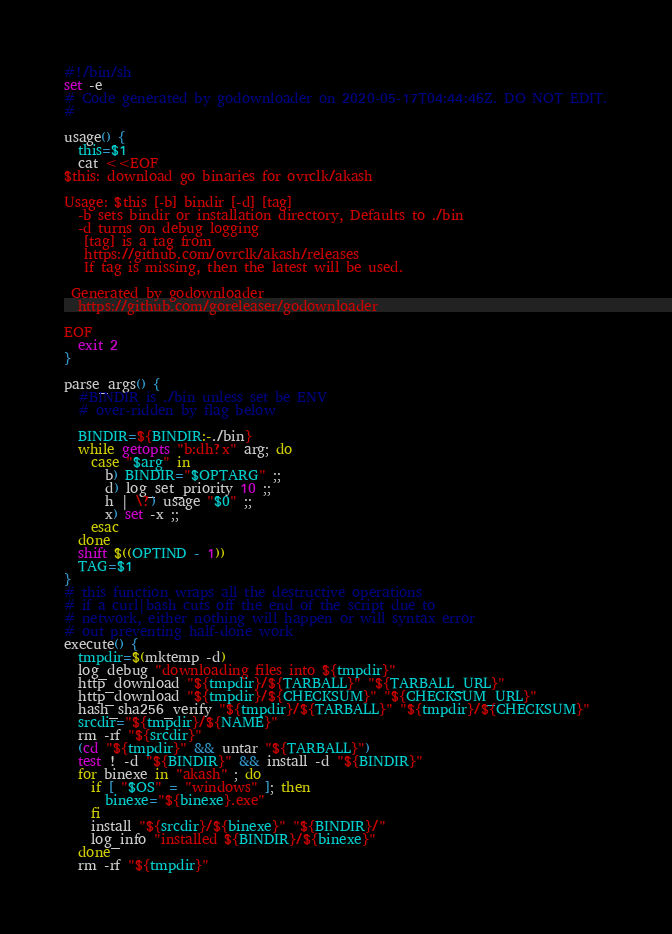<code> <loc_0><loc_0><loc_500><loc_500><_Bash_>#!/bin/sh
set -e
# Code generated by godownloader on 2020-05-17T04:44:46Z. DO NOT EDIT.
#

usage() {
  this=$1
  cat <<EOF
$this: download go binaries for ovrclk/akash

Usage: $this [-b] bindir [-d] [tag]
  -b sets bindir or installation directory, Defaults to ./bin
  -d turns on debug logging
   [tag] is a tag from
   https://github.com/ovrclk/akash/releases
   If tag is missing, then the latest will be used.

 Generated by godownloader
  https://github.com/goreleaser/godownloader

EOF
  exit 2
}

parse_args() {
  #BINDIR is ./bin unless set be ENV
  # over-ridden by flag below

  BINDIR=${BINDIR:-./bin}
  while getopts "b:dh?x" arg; do
    case "$arg" in
      b) BINDIR="$OPTARG" ;;
      d) log_set_priority 10 ;;
      h | \?) usage "$0" ;;
      x) set -x ;;
    esac
  done
  shift $((OPTIND - 1))
  TAG=$1
}
# this function wraps all the destructive operations
# if a curl|bash cuts off the end of the script due to
# network, either nothing will happen or will syntax error
# out preventing half-done work
execute() {
  tmpdir=$(mktemp -d)
  log_debug "downloading files into ${tmpdir}"
  http_download "${tmpdir}/${TARBALL}" "${TARBALL_URL}"
  http_download "${tmpdir}/${CHECKSUM}" "${CHECKSUM_URL}"
  hash_sha256_verify "${tmpdir}/${TARBALL}" "${tmpdir}/${CHECKSUM}"
  srcdir="${tmpdir}/${NAME}"
  rm -rf "${srcdir}"
  (cd "${tmpdir}" && untar "${TARBALL}")
  test ! -d "${BINDIR}" && install -d "${BINDIR}"
  for binexe in "akash" ; do
    if [ "$OS" = "windows" ]; then
      binexe="${binexe}.exe"
    fi
    install "${srcdir}/${binexe}" "${BINDIR}/"
    log_info "installed ${BINDIR}/${binexe}"
  done
  rm -rf "${tmpdir}"</code> 